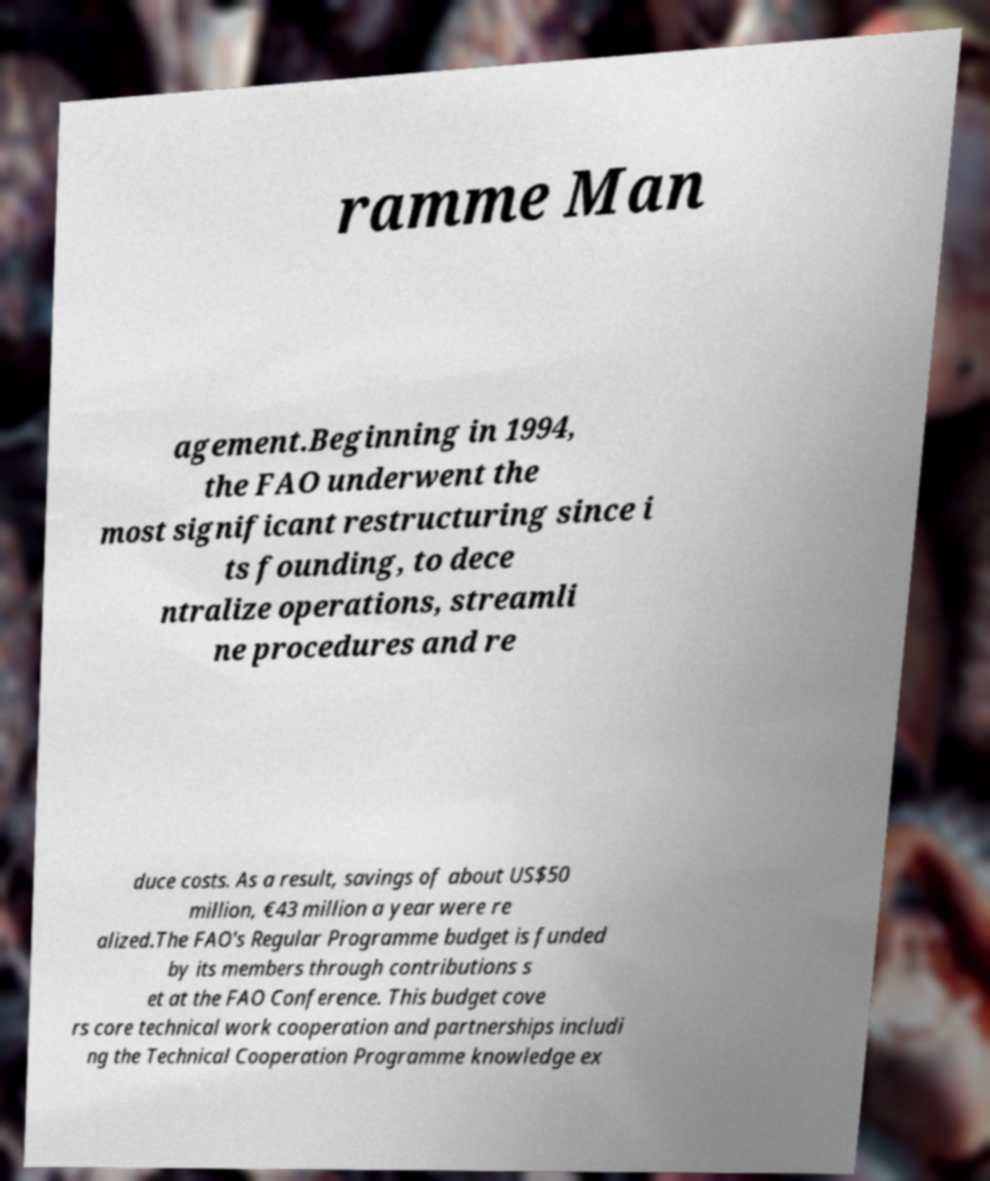There's text embedded in this image that I need extracted. Can you transcribe it verbatim? ramme Man agement.Beginning in 1994, the FAO underwent the most significant restructuring since i ts founding, to dece ntralize operations, streamli ne procedures and re duce costs. As a result, savings of about US$50 million, €43 million a year were re alized.The FAO's Regular Programme budget is funded by its members through contributions s et at the FAO Conference. This budget cove rs core technical work cooperation and partnerships includi ng the Technical Cooperation Programme knowledge ex 